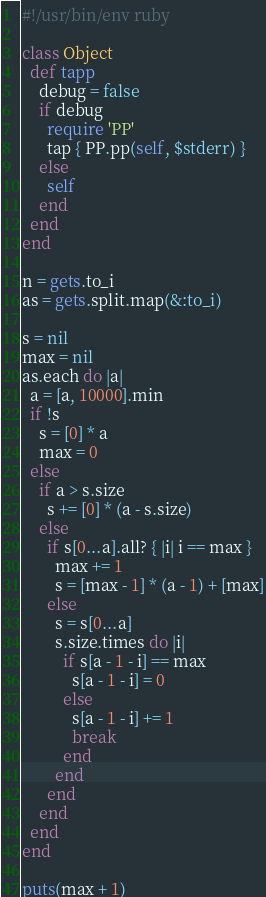<code> <loc_0><loc_0><loc_500><loc_500><_Ruby_>#!/usr/bin/env ruby

class Object
  def tapp
    debug = false
    if debug
      require 'PP'
      tap { PP.pp(self, $stderr) }
    else
      self
    end
  end
end

n = gets.to_i
as = gets.split.map(&:to_i)

s = nil
max = nil
as.each do |a|
  a = [a, 10000].min
  if !s
    s = [0] * a
    max = 0
  else
    if a > s.size
      s += [0] * (a - s.size)
    else
      if s[0...a].all? { |i| i == max }
        max += 1
        s = [max - 1] * (a - 1) + [max]
      else
        s = s[0...a]
        s.size.times do |i|
          if s[a - 1 - i] == max
            s[a - 1 - i] = 0
          else
            s[a - 1 - i] += 1
            break
          end
        end
      end
    end
  end
end

puts(max + 1)</code> 